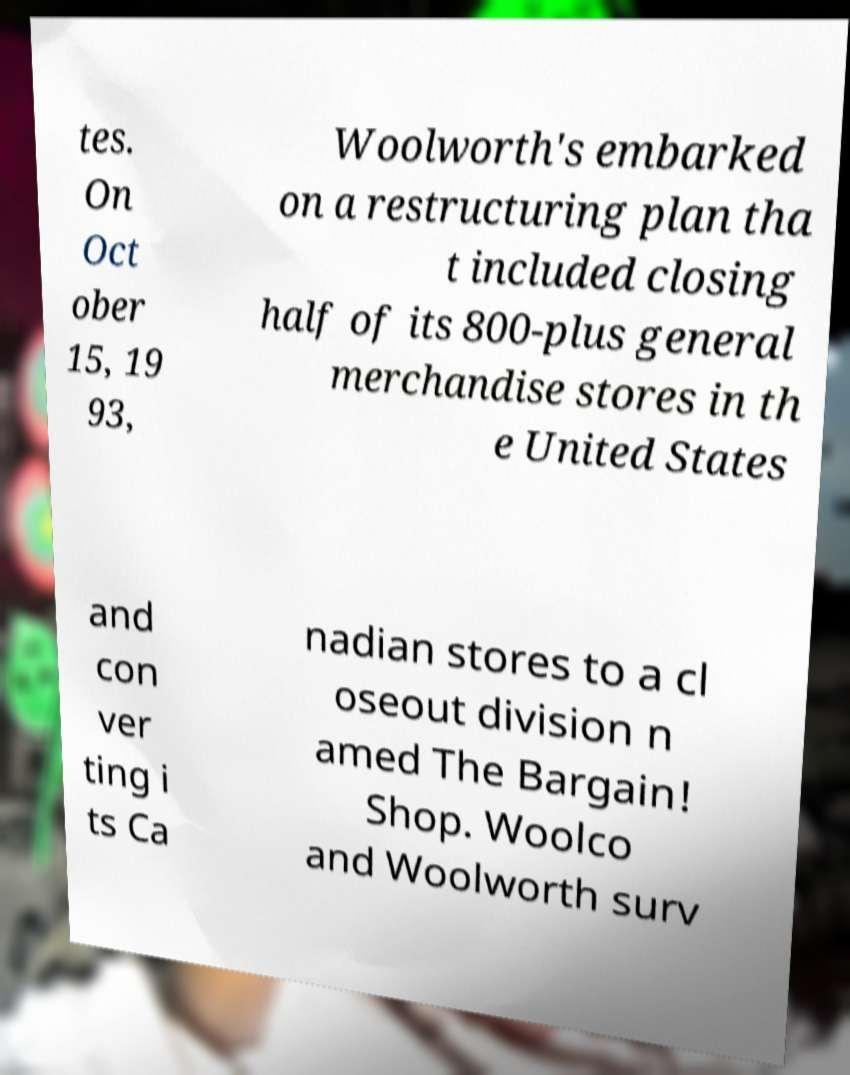Please read and relay the text visible in this image. What does it say? tes. On Oct ober 15, 19 93, Woolworth's embarked on a restructuring plan tha t included closing half of its 800-plus general merchandise stores in th e United States and con ver ting i ts Ca nadian stores to a cl oseout division n amed The Bargain! Shop. Woolco and Woolworth surv 